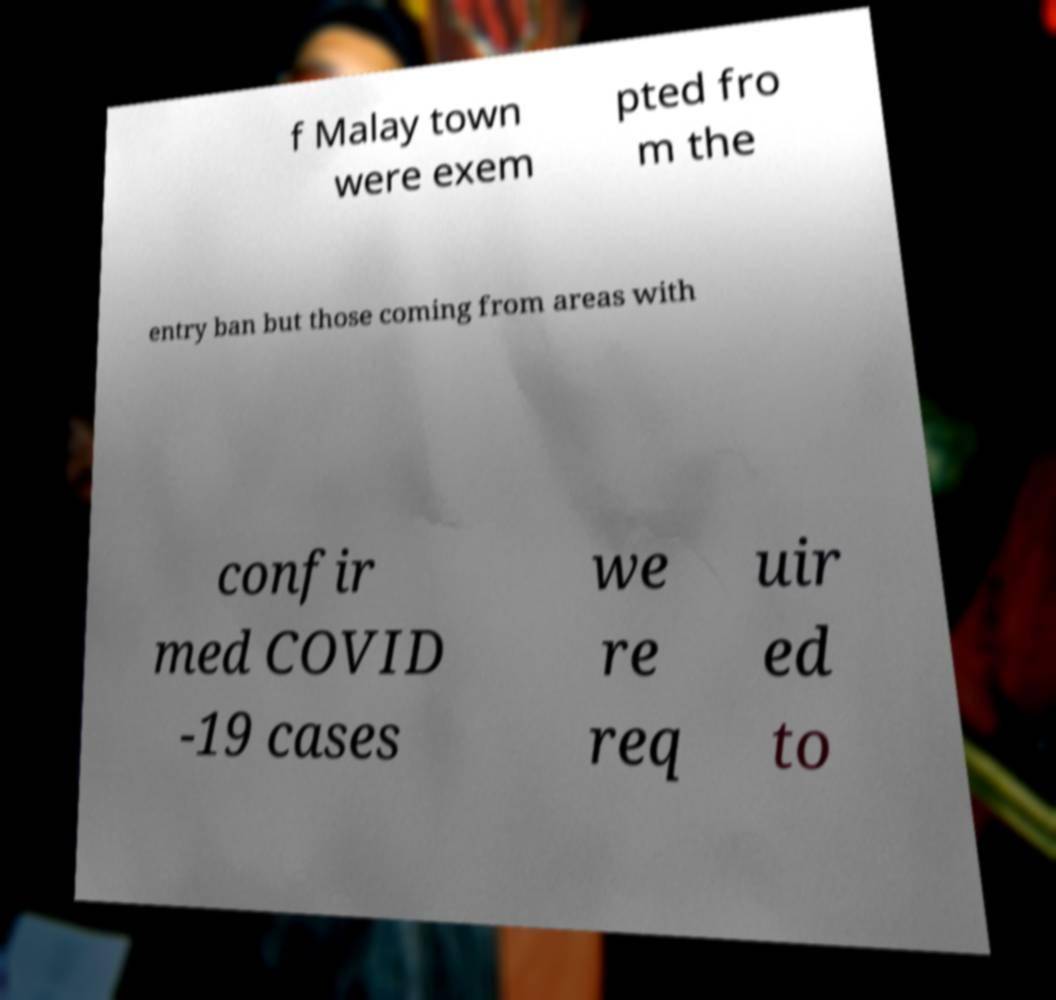Can you accurately transcribe the text from the provided image for me? f Malay town were exem pted fro m the entry ban but those coming from areas with confir med COVID -19 cases we re req uir ed to 